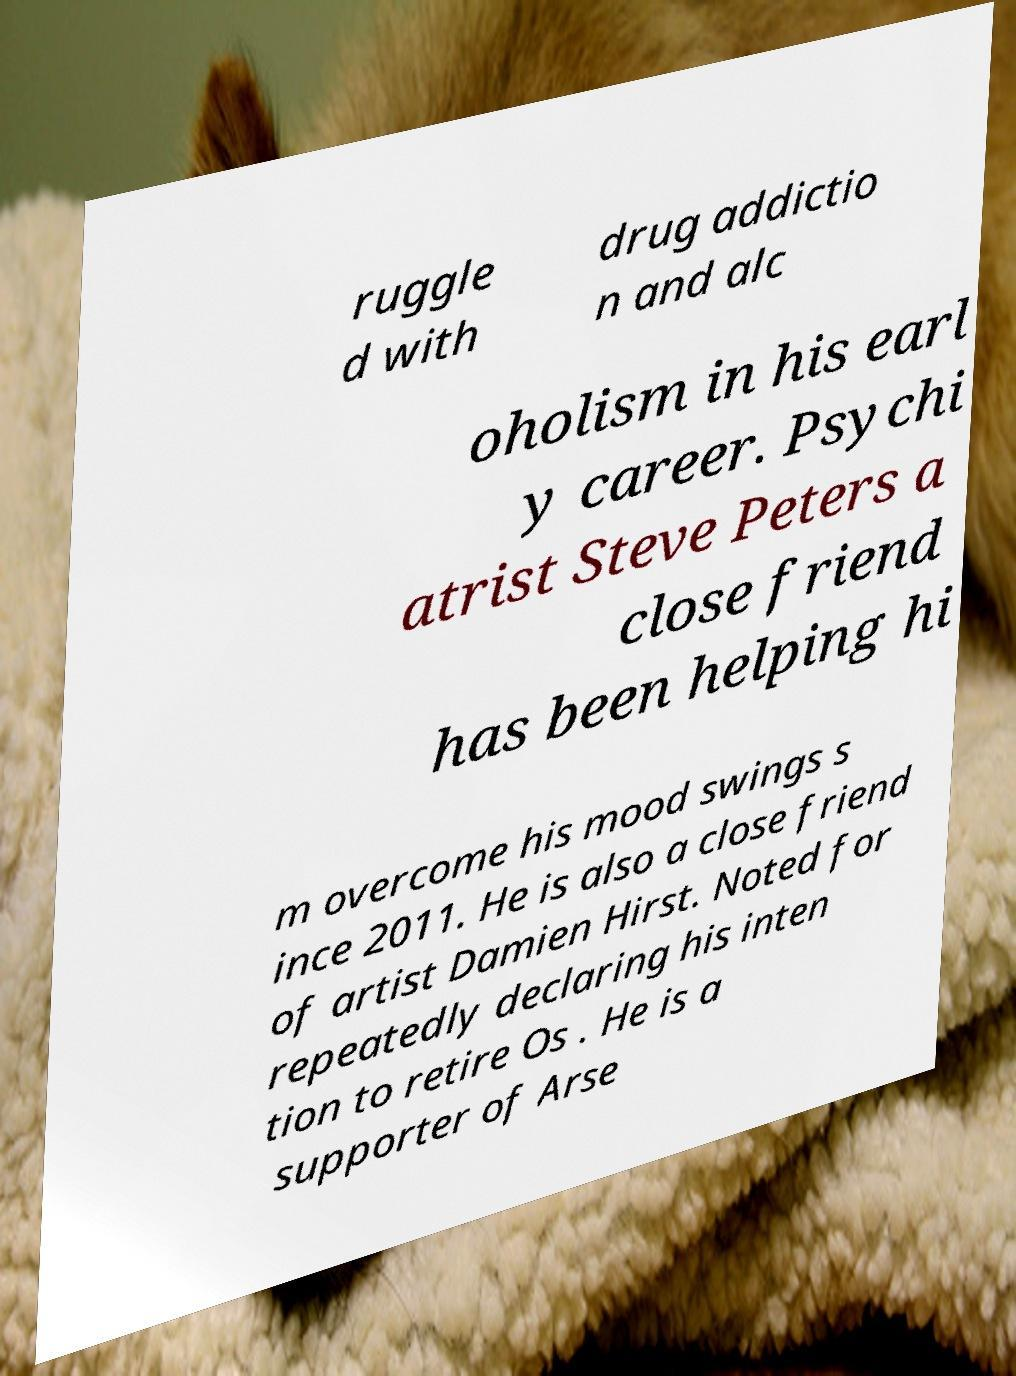There's text embedded in this image that I need extracted. Can you transcribe it verbatim? ruggle d with drug addictio n and alc oholism in his earl y career. Psychi atrist Steve Peters a close friend has been helping hi m overcome his mood swings s ince 2011. He is also a close friend of artist Damien Hirst. Noted for repeatedly declaring his inten tion to retire Os . He is a supporter of Arse 